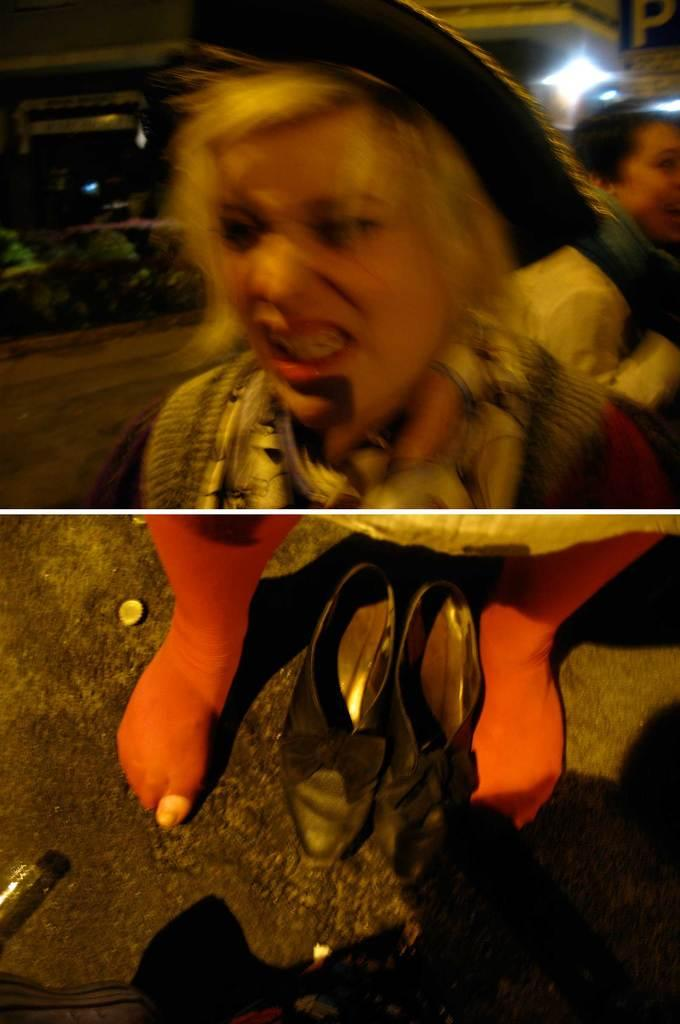What is the main subject of the image? The main subject of the image is a blurred face of a person. What else can be seen in the image besides the person's face? There is a pair of footwear and the legs of a person visible in the image. What type of soda is the person holding in the image? There is no soda present in the image; the person's face is blurred, and no other objects are mentioned. 